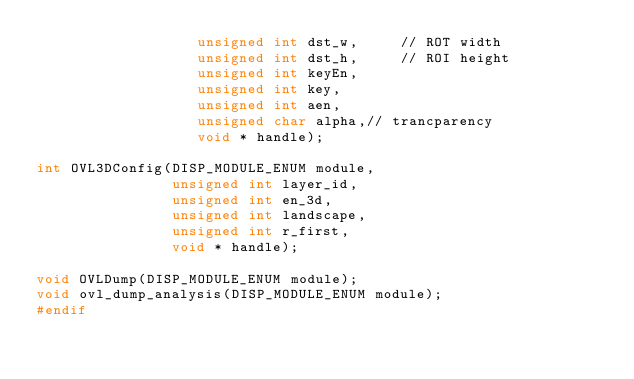<code> <loc_0><loc_0><loc_500><loc_500><_C_>                   unsigned int dst_w,     // ROT width
                   unsigned int dst_h,     // ROI height
                   unsigned int keyEn,
                   unsigned int key,
                   unsigned int aen,
                   unsigned char alpha,// trancparency
                   void * handle);

int OVL3DConfig(DISP_MODULE_ENUM module,
                unsigned int layer_id,
                unsigned int en_3d,
                unsigned int landscape,
                unsigned int r_first,
                void * handle);

void OVLDump(DISP_MODULE_ENUM module);
void ovl_dump_analysis(DISP_MODULE_ENUM module);
#endif
</code> 